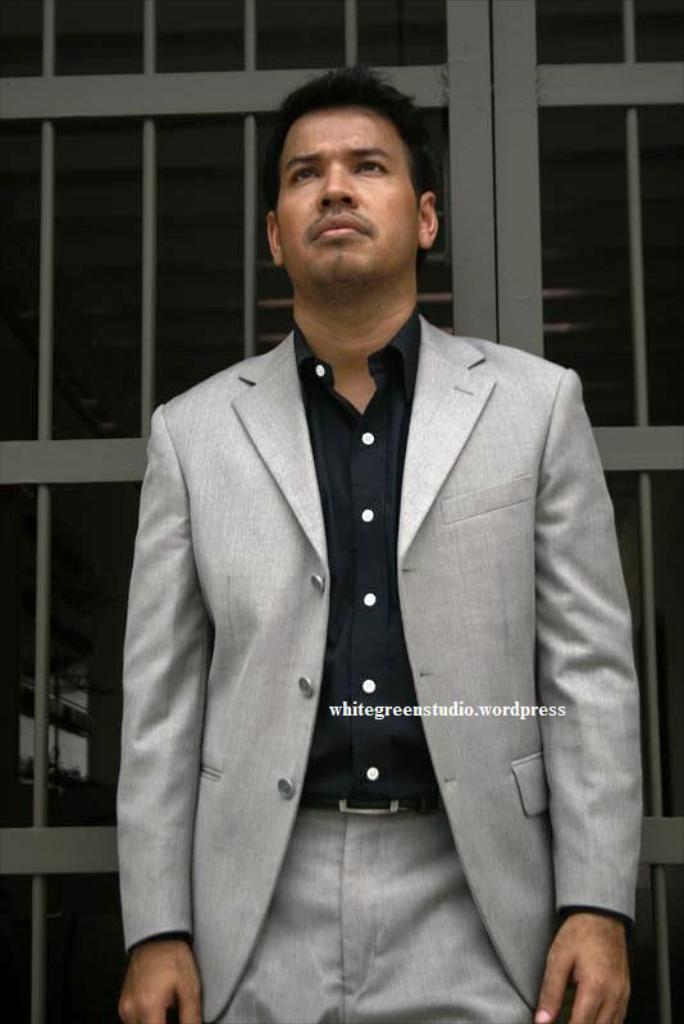Describe this image in one or two sentences. Here I can see a man wearing a suit, standing and looking at the upwards. In the background there is a metal frame. On this image, I can see some edited text. 